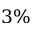<formula> <loc_0><loc_0><loc_500><loc_500>3 \%</formula> 